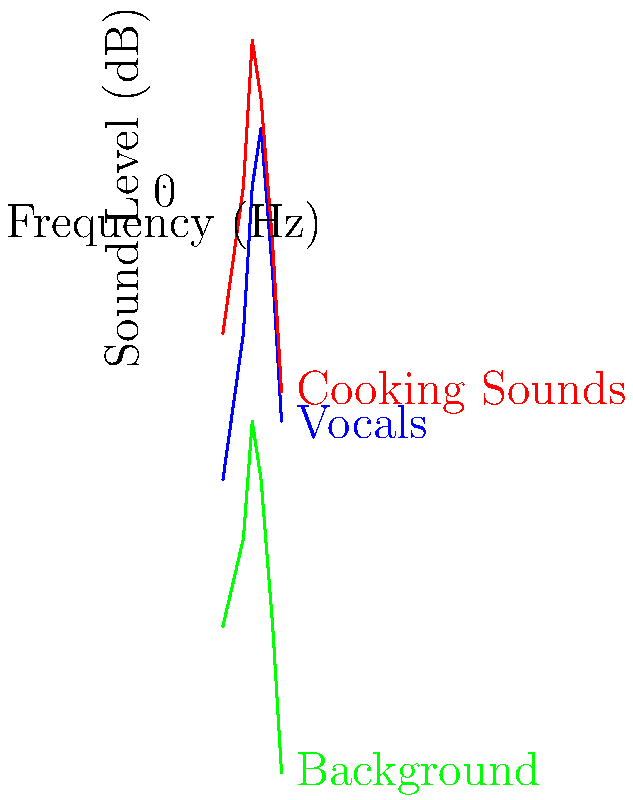In the audio mixing graph for a cooking show, which frequency range shows the highest sound level for cooking sounds, and how does this compare to the vocals in the same range? To answer this question, we need to analyze the graph step-by-step:

1. Identify the line representing cooking sounds (red line).
2. Locate the peak of the red line, which occurs around 1000 Hz.
3. At 1000 Hz, the cooking sounds have a sound level of about 5 dB.
4. Compare this to the vocals (blue line) at the same frequency:
   - At 1000 Hz, the vocals have a sound level of about 0 dB.
5. Calculate the difference:
   $5 \text{ dB} - 0 \text{ dB} = 5 \text{ dB}$

Therefore, in the 1000 Hz range, cooking sounds are approximately 5 dB higher than vocals.
Answer: 1000 Hz range; 5 dB higher than vocals 